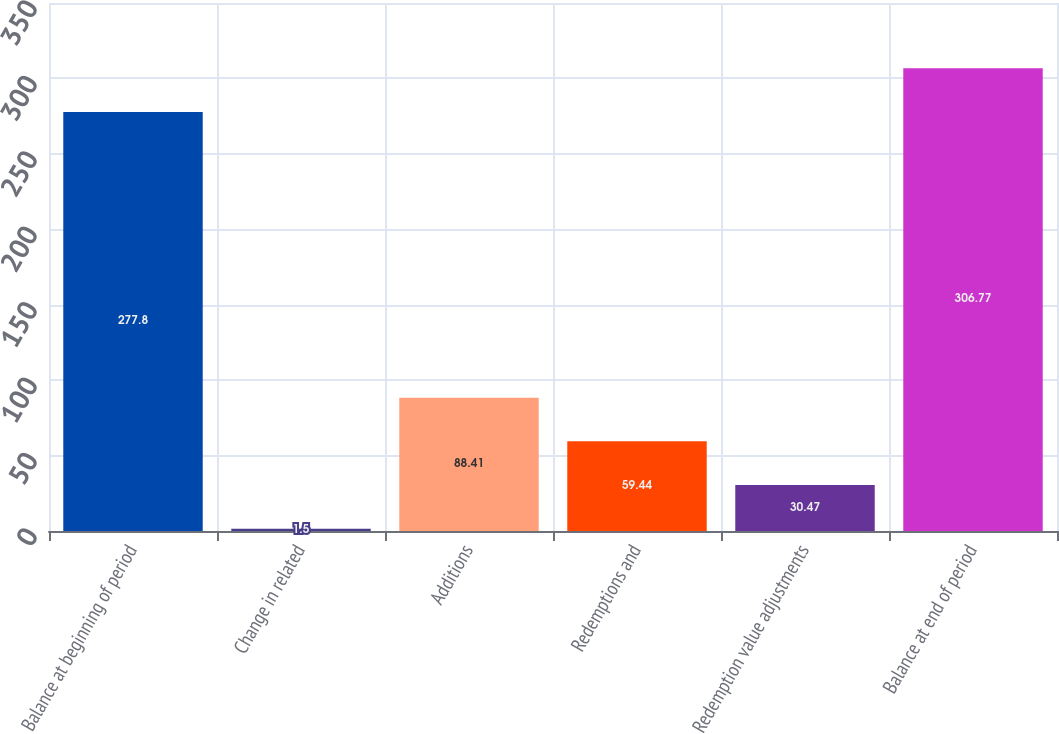Convert chart to OTSL. <chart><loc_0><loc_0><loc_500><loc_500><bar_chart><fcel>Balance at beginning of period<fcel>Change in related<fcel>Additions<fcel>Redemptions and<fcel>Redemption value adjustments<fcel>Balance at end of period<nl><fcel>277.8<fcel>1.5<fcel>88.41<fcel>59.44<fcel>30.47<fcel>306.77<nl></chart> 